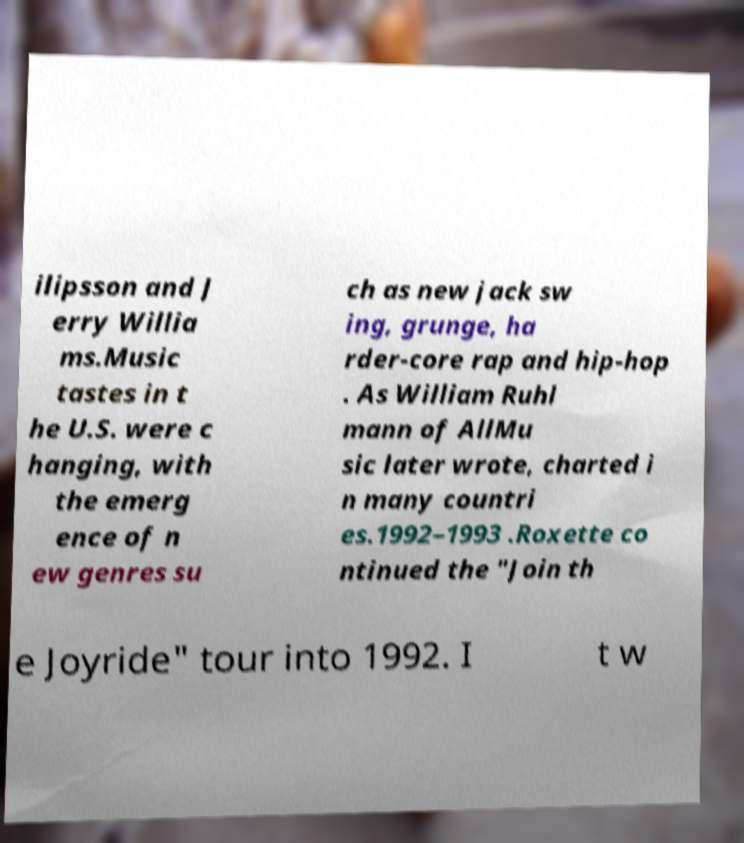Please read and relay the text visible in this image. What does it say? ilipsson and J erry Willia ms.Music tastes in t he U.S. were c hanging, with the emerg ence of n ew genres su ch as new jack sw ing, grunge, ha rder-core rap and hip-hop . As William Ruhl mann of AllMu sic later wrote, charted i n many countri es.1992–1993 .Roxette co ntinued the "Join th e Joyride" tour into 1992. I t w 